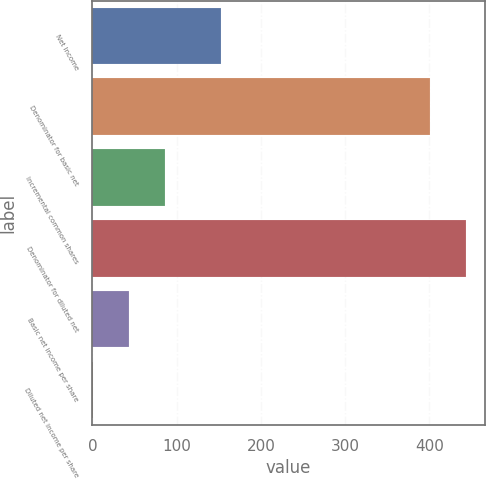<chart> <loc_0><loc_0><loc_500><loc_500><bar_chart><fcel>Net Income<fcel>Denominator for basic net<fcel>Incremental common shares<fcel>Denominator for diluted net<fcel>Basic net income per share<fcel>Diluted net income per share<nl><fcel>153<fcel>401<fcel>85.88<fcel>443.76<fcel>43.12<fcel>0.36<nl></chart> 